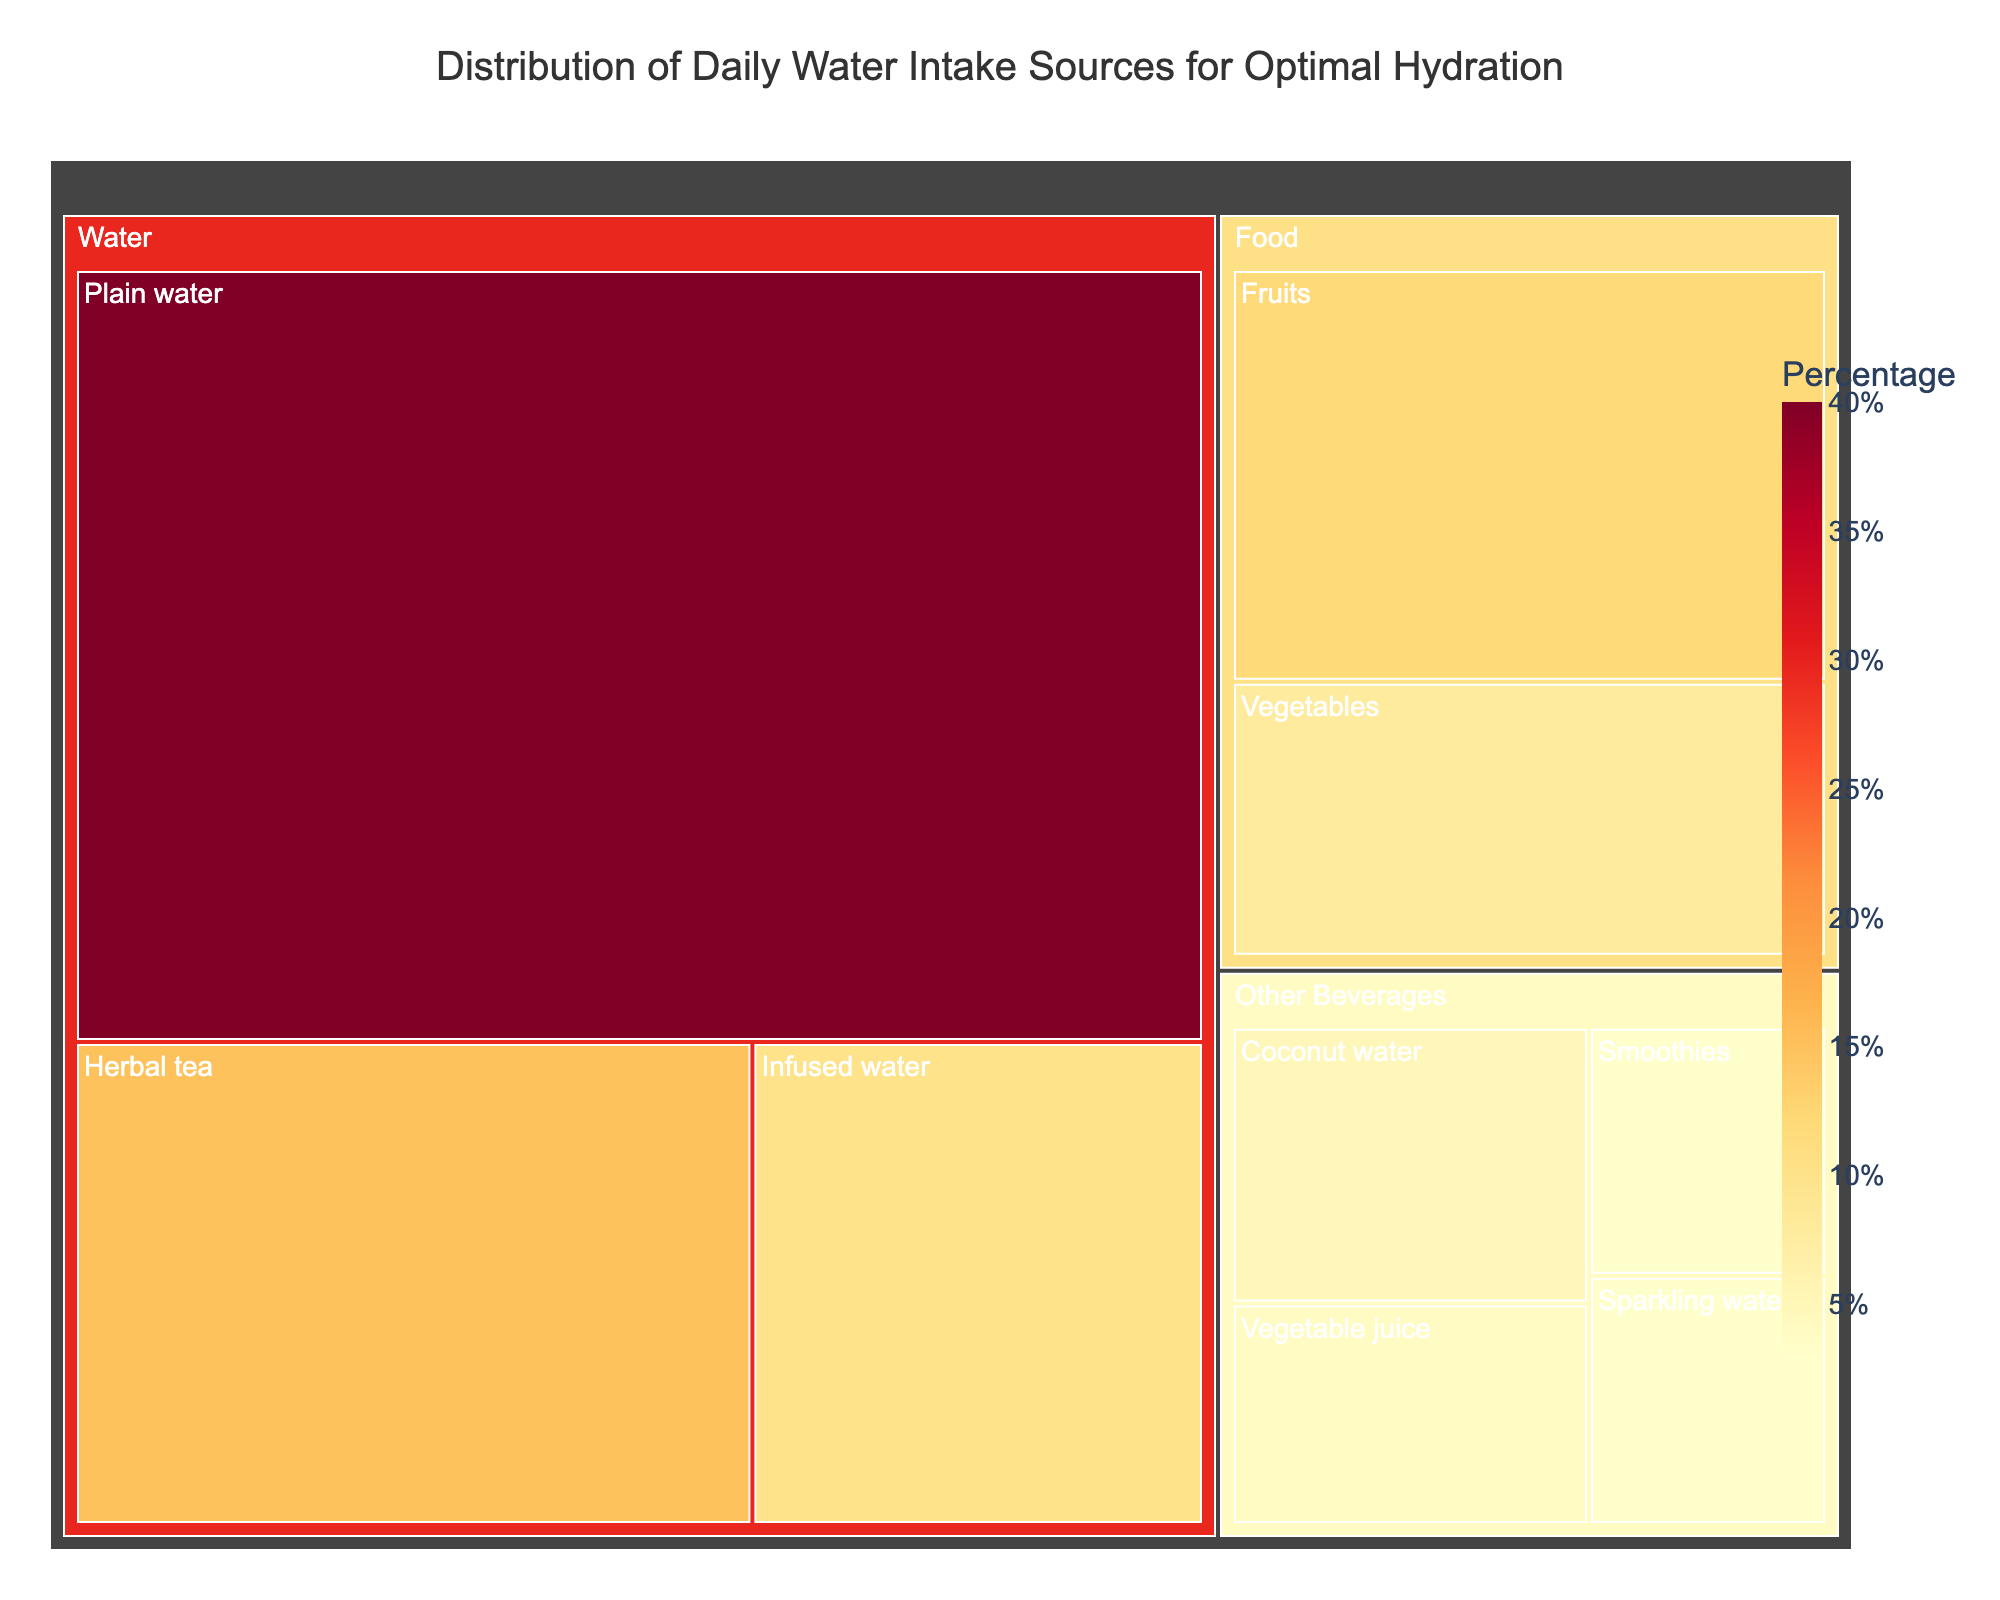What's the largest category for daily water intake? The largest category can be identified by looking at the size of the blocks in the treemap. The "Water" category has the largest blocks.
Answer: Water What's the smallest subcategory under "Other Beverages"? The smallest subcategory under "Other Beverages" can be identified by the smallest block size within that category. "Sparkling water" has the smallest block.
Answer: Sparkling water What percentage of daily water intake comes from food sources? To calculate the percentage from food sources, sum the values of "Fruits" and "Vegetables" and compare it to the total. The total is 100% (sum of all values). So, (12 + 8) / 100 = 20%.
Answer: 20% Which subcategory has the second highest value in the "Water" category? To find the second highest value in the "Water" category, look at the block sizes in descending order. "Herbal tea" has the second highest value after "Plain water".
Answer: Herbal tea Compare the total value of "Other Beverages" to "Food". Which is higher? Sum the values within "Other Beverages" and "Food" categories, then compare the sums. "Other Beverages" total is 5 + 4 + 3 + 3 = 15 and "Food" total is 12 + 8 = 20, so "Food" is higher.
Answer: Food What is the combined value of "Infused water" and "Coconut water"? Add the values of "Infused water" and "Coconut water". 10 + 5 = 15.
Answer: 15 What percentage of daily intake does "Vegetable juice" contribute? "Vegetable juice" value is 4 out of a total of 100, giving a percentage of 4%.
Answer: 4% Which has a larger value: "Smoothies" or "Infused water"? Compare the values directly. "Smoothies" has 3, while "Infused water" has 10. Infused water is larger.
Answer: Infused water What's the title of the figure? The title is displayed at the top of the treemap. The title is "Distribution of Daily Water Intake Sources for Optimal Hydration".
Answer: Distribution of Daily Water Intake Sources for Optimal Hydration List all subcategories under "Other Beverages". The subcategories are visible under the "Other Beverages" category block. They are "Coconut water", "Vegetable juice", "Smoothies", and "Sparkling water".
Answer: Coconut water, Vegetable juice, Smoothies, Sparkling water 